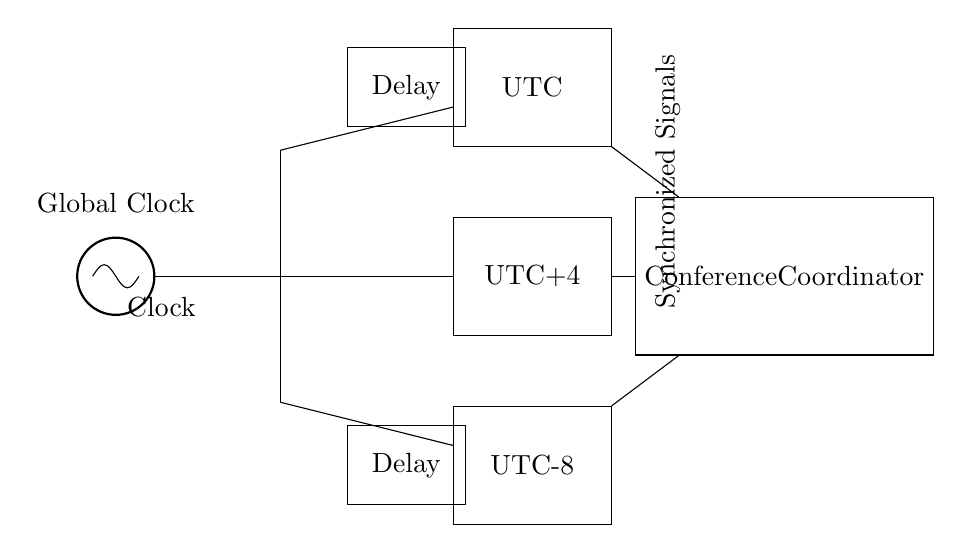What is the primary component used for time synchronization? The primary component used for time synchronization in this circuit is the clock oscillator, as seen at the beginning of the circuit diagram. It generates the consistent timing signal needed for the synchronous function.
Answer: Clock What are the three time zones represented in the circuit? The three time zones represented in the circuit are UTC, UTC+4, and UTC-8, indicated by the respective blocks in the circuit diagram. Each block corresponds to a different time zone for coordinating calls.
Answer: UTC, UTC+4, UTC-8 How many delay elements are present in the circuit? There are two delay elements indicated in the diagram, which can be identified by their representation as blocks labeled "Delay." They adjust the timing for participants in different time zones.
Answer: Two Which component acts as the central coordinator for the calls? The central coordinator for the calls is the component labeled "Conference Coordinator," which receives synchronized signals from all time zones to manage the meeting schedule.
Answer: Conference Coordinator What do the connections from the clock to the time zone blocks represent? The connections from the clock to the time zone blocks represent the distribution of the clock signal across different geographic locations, ensuring all participants receive the same time reference.
Answer: Synchronized Signals What is the purpose of the delay elements in this circuit? The purpose of the delay elements is to adjust the timing of the signals sent to the time zone blocks, allowing for any discrepancies in the time offset for different regions to be accounted for within the synchronous calls.
Answer: Adjust timing 